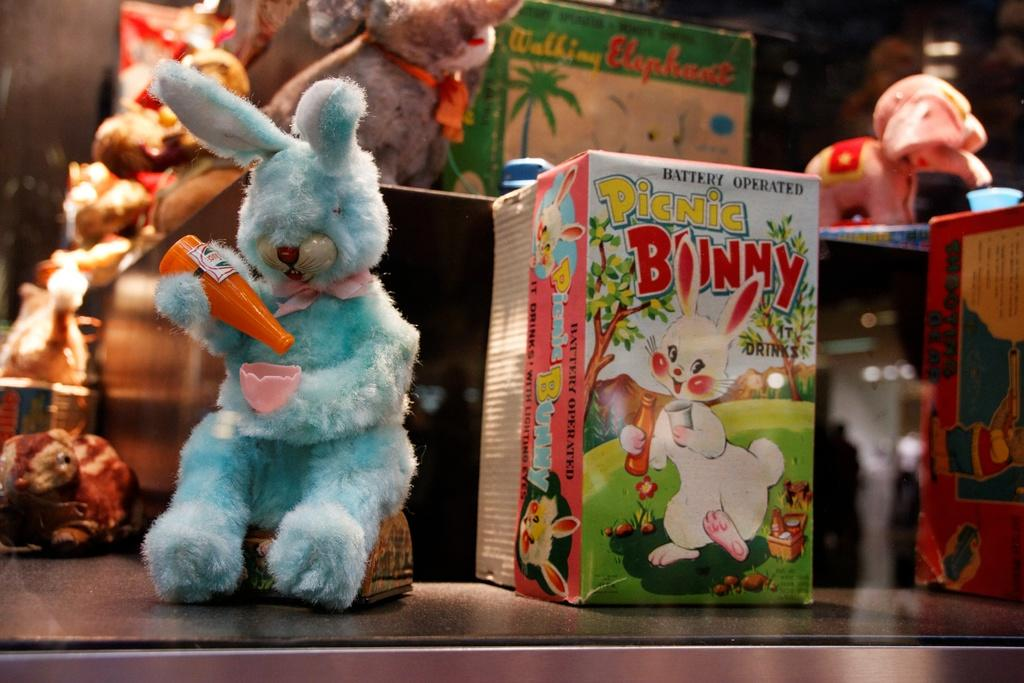What types of toys are present in the image? There are many dolls, a toy rabbit, and an elephant in the image. Can you describe the toy rabbit in the image? The toy rabbit is in blue color and is located in the front of the image. Is the toy rabbit a part of the dolls? Yes, the toy rabbit is a part of the dolls. What color is the elephant in the image? The elephant is in pink color. Is the elephant also a part of the dolls? Yes, the elephant is also a part of the dolls. Where are the toys kept in the image? The toys are kept on a desk. What type of wine is being served in the image? There is no wine present in the image; it features toys such as dolls, a toy rabbit, and an elephant on a desk. 